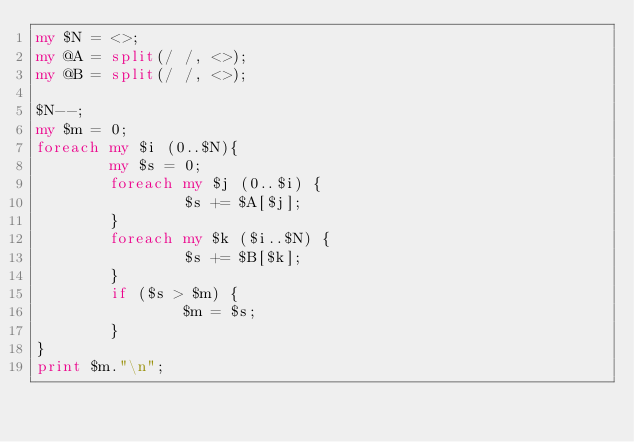Convert code to text. <code><loc_0><loc_0><loc_500><loc_500><_Perl_>my $N = <>;
my @A = split(/ /, <>);
my @B = split(/ /, <>);

$N--;
my $m = 0;
foreach my $i (0..$N){
        my $s = 0;
        foreach my $j (0..$i) {
                $s += $A[$j];
        }
        foreach my $k ($i..$N) {
                $s += $B[$k];
        }
        if ($s > $m) {
                $m = $s;
        }
}
print $m."\n";</code> 